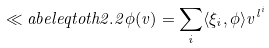<formula> <loc_0><loc_0><loc_500><loc_500>\ll a b e l { e q t o t h 2 . 2 } \phi ( v ) = \sum _ { i } \langle \xi _ { i } , \phi \rangle v ^ { l ^ { i } }</formula> 